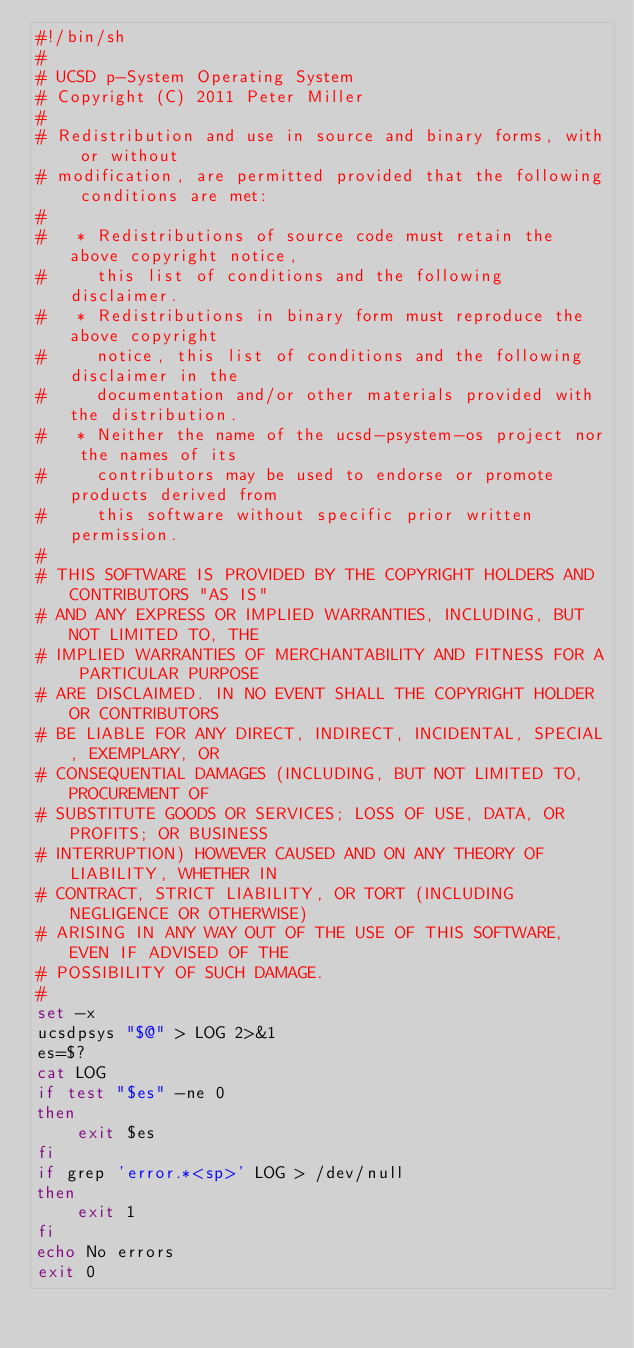Convert code to text. <code><loc_0><loc_0><loc_500><loc_500><_Bash_>#!/bin/sh
#
# UCSD p-System Operating System
# Copyright (C) 2011 Peter Miller
#
# Redistribution and use in source and binary forms, with or without
# modification, are permitted provided that the following conditions are met:
#
#   * Redistributions of source code must retain the above copyright notice,
#     this list of conditions and the following disclaimer.
#   * Redistributions in binary form must reproduce the above copyright
#     notice, this list of conditions and the following disclaimer in the
#     documentation and/or other materials provided with the distribution.
#   * Neither the name of the ucsd-psystem-os project nor the names of its
#     contributors may be used to endorse or promote products derived from
#     this software without specific prior written permission.
#
# THIS SOFTWARE IS PROVIDED BY THE COPYRIGHT HOLDERS AND CONTRIBUTORS "AS IS"
# AND ANY EXPRESS OR IMPLIED WARRANTIES, INCLUDING, BUT NOT LIMITED TO, THE
# IMPLIED WARRANTIES OF MERCHANTABILITY AND FITNESS FOR A PARTICULAR PURPOSE
# ARE DISCLAIMED. IN NO EVENT SHALL THE COPYRIGHT HOLDER OR CONTRIBUTORS
# BE LIABLE FOR ANY DIRECT, INDIRECT, INCIDENTAL, SPECIAL, EXEMPLARY, OR
# CONSEQUENTIAL DAMAGES (INCLUDING, BUT NOT LIMITED TO, PROCUREMENT OF
# SUBSTITUTE GOODS OR SERVICES; LOSS OF USE, DATA, OR PROFITS; OR BUSINESS
# INTERRUPTION) HOWEVER CAUSED AND ON ANY THEORY OF LIABILITY, WHETHER IN
# CONTRACT, STRICT LIABILITY, OR TORT (INCLUDING NEGLIGENCE OR OTHERWISE)
# ARISING IN ANY WAY OUT OF THE USE OF THIS SOFTWARE, EVEN IF ADVISED OF THE
# POSSIBILITY OF SUCH DAMAGE.
#
set -x
ucsdpsys "$@" > LOG 2>&1
es=$?
cat LOG
if test "$es" -ne 0
then
    exit $es
fi
if grep 'error.*<sp>' LOG > /dev/null
then
    exit 1
fi
echo No errors
exit 0
</code> 